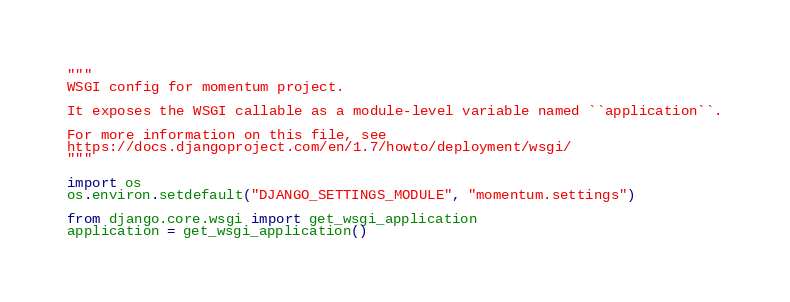Convert code to text. <code><loc_0><loc_0><loc_500><loc_500><_Python_>"""
WSGI config for momentum project.

It exposes the WSGI callable as a module-level variable named ``application``.

For more information on this file, see
https://docs.djangoproject.com/en/1.7/howto/deployment/wsgi/
"""

import os
os.environ.setdefault("DJANGO_SETTINGS_MODULE", "momentum.settings")

from django.core.wsgi import get_wsgi_application
application = get_wsgi_application()
</code> 